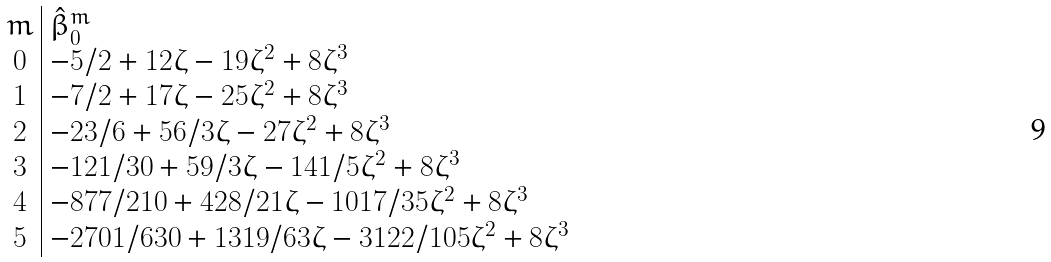Convert formula to latex. <formula><loc_0><loc_0><loc_500><loc_500>\begin{array} { c | l } m & \hat { \beta } _ { 0 } ^ { m } \\ 0 & - 5 / 2 + 1 2 \zeta - 1 9 \zeta ^ { 2 } + 8 \zeta ^ { 3 } \\ 1 & - 7 / 2 + 1 7 \zeta - 2 5 \zeta ^ { 2 } + 8 \zeta ^ { 3 } \\ 2 & - 2 3 / 6 + 5 6 / 3 \zeta - 2 7 \zeta ^ { 2 } + 8 \zeta ^ { 3 } \\ 3 & - 1 2 1 / 3 0 + 5 9 / 3 \zeta - 1 4 1 / 5 \zeta ^ { 2 } + 8 \zeta ^ { 3 } \\ 4 & - 8 7 7 / 2 1 0 + 4 2 8 / 2 1 \zeta - 1 0 1 7 / 3 5 \zeta ^ { 2 } + 8 \zeta ^ { 3 } \\ 5 & - 2 7 0 1 / 6 3 0 + 1 3 1 9 / 6 3 \zeta - 3 1 2 2 / 1 0 5 \zeta ^ { 2 } + 8 \zeta ^ { 3 } \end{array}</formula> 